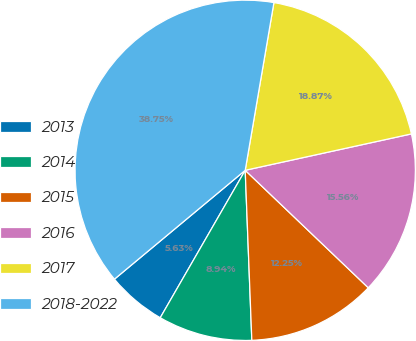Convert chart. <chart><loc_0><loc_0><loc_500><loc_500><pie_chart><fcel>2013<fcel>2014<fcel>2015<fcel>2016<fcel>2017<fcel>2018-2022<nl><fcel>5.63%<fcel>8.94%<fcel>12.25%<fcel>15.56%<fcel>18.87%<fcel>38.75%<nl></chart> 